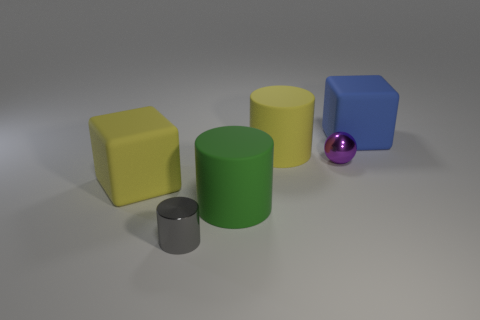How big is the purple object?
Provide a short and direct response. Small. There is a yellow block that is the same size as the green rubber cylinder; what is its material?
Keep it short and to the point. Rubber. There is a shiny cylinder; what number of large blue matte objects are behind it?
Your answer should be very brief. 1. Is the block to the right of the small metal cylinder made of the same material as the big yellow thing on the left side of the big yellow matte cylinder?
Ensure brevity in your answer.  Yes. What is the shape of the purple metallic object in front of the large blue object that is behind the shiny object that is behind the big green thing?
Make the answer very short. Sphere. The purple shiny thing has what shape?
Your response must be concise. Sphere. What is the shape of the purple thing that is the same size as the gray shiny thing?
Offer a terse response. Sphere. What number of other things are there of the same color as the sphere?
Your response must be concise. 0. There is a big rubber object that is on the right side of the small shiny sphere; does it have the same shape as the yellow thing in front of the purple shiny ball?
Offer a terse response. Yes. How many objects are large objects on the left side of the big blue thing or large rubber cubes that are on the right side of the small purple ball?
Your answer should be very brief. 4. 